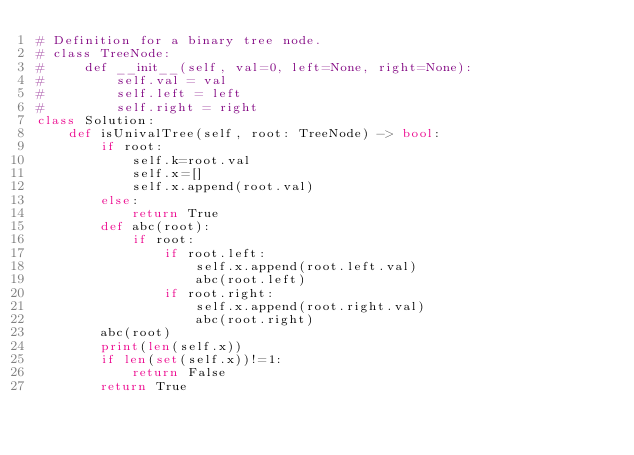Convert code to text. <code><loc_0><loc_0><loc_500><loc_500><_Python_># Definition for a binary tree node.
# class TreeNode:
#     def __init__(self, val=0, left=None, right=None):
#         self.val = val
#         self.left = left
#         self.right = right
class Solution:
    def isUnivalTree(self, root: TreeNode) -> bool:
        if root:
            self.k=root.val
            self.x=[]
            self.x.append(root.val)
        else:
            return True
        def abc(root):
            if root:
                if root.left:
                    self.x.append(root.left.val)
                    abc(root.left)
                if root.right:
                    self.x.append(root.right.val)
                    abc(root.right)
        abc(root)
        print(len(self.x))
        if len(set(self.x))!=1:
            return False
        return True
            

                
                
            
</code> 